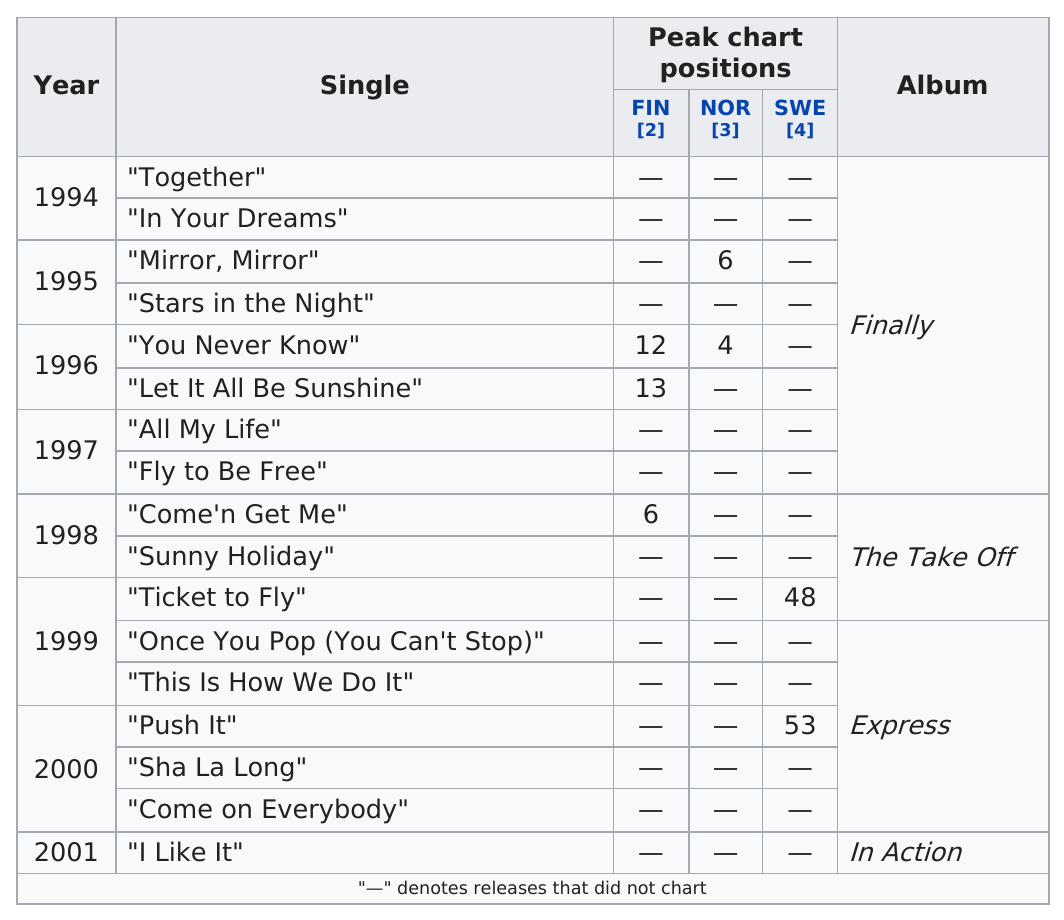Highlight a few significant elements in this photo. The Beatles' album 'Abbey Road' reached the highest peak chart position, peaking at number one on the UK and US album charts, followed by 'The Beatles' and 'The Beatles (White Album)' The song that reached the highest position on the Finnish singles chart is a solid base single with a peaked structure and is characterized by a strong and catchy melody, making it a popular and memorable hit among listeners. The solid base album with the most charting singles is [the album's name]. Three solid base singles have charted on the Finnish singles chart. 